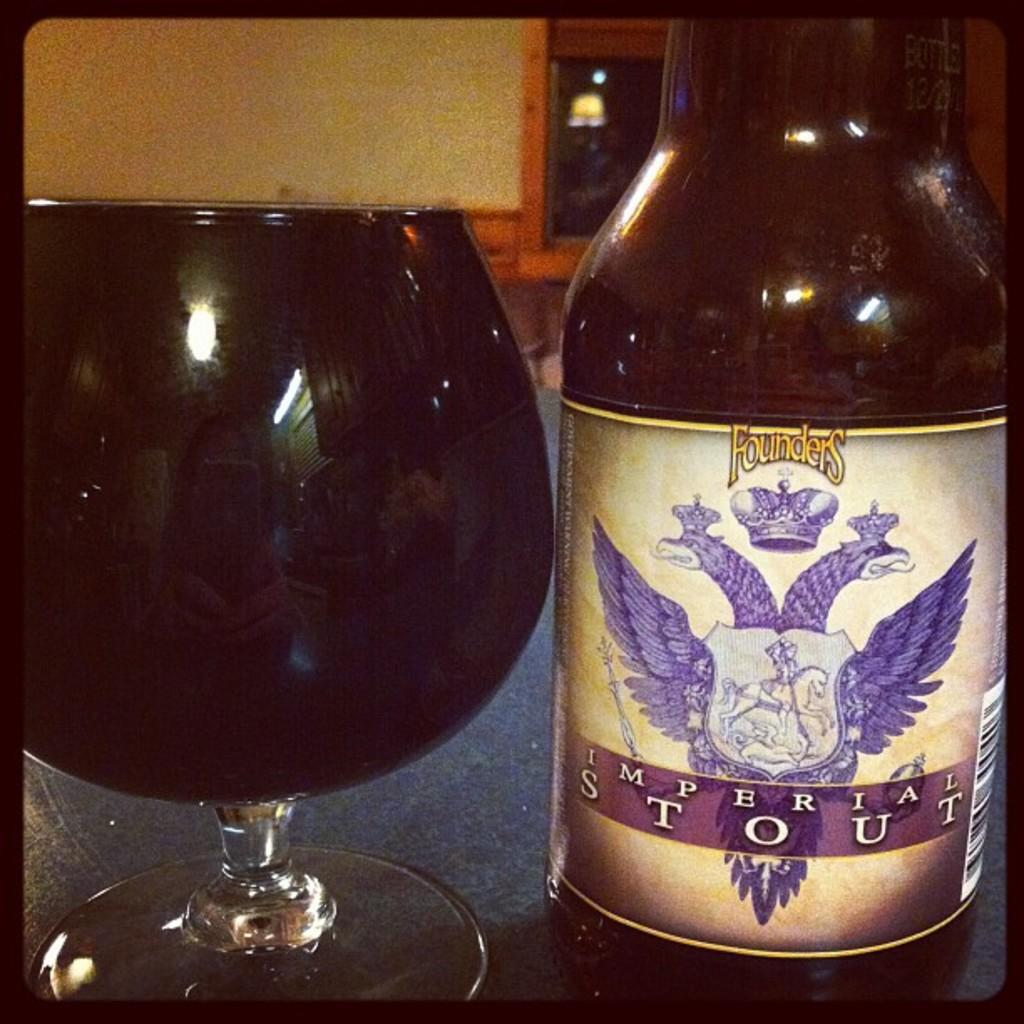<image>
Relay a brief, clear account of the picture shown. A bottle of Imperial stout next to a glass. 